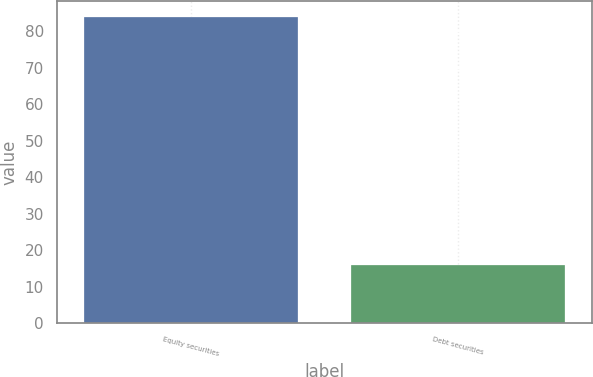Convert chart to OTSL. <chart><loc_0><loc_0><loc_500><loc_500><bar_chart><fcel>Equity securities<fcel>Debt securities<nl><fcel>84<fcel>16<nl></chart> 